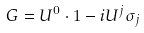<formula> <loc_0><loc_0><loc_500><loc_500>\ G = U ^ { 0 } \cdot { 1 } - i U ^ { j } \sigma _ { j }</formula> 